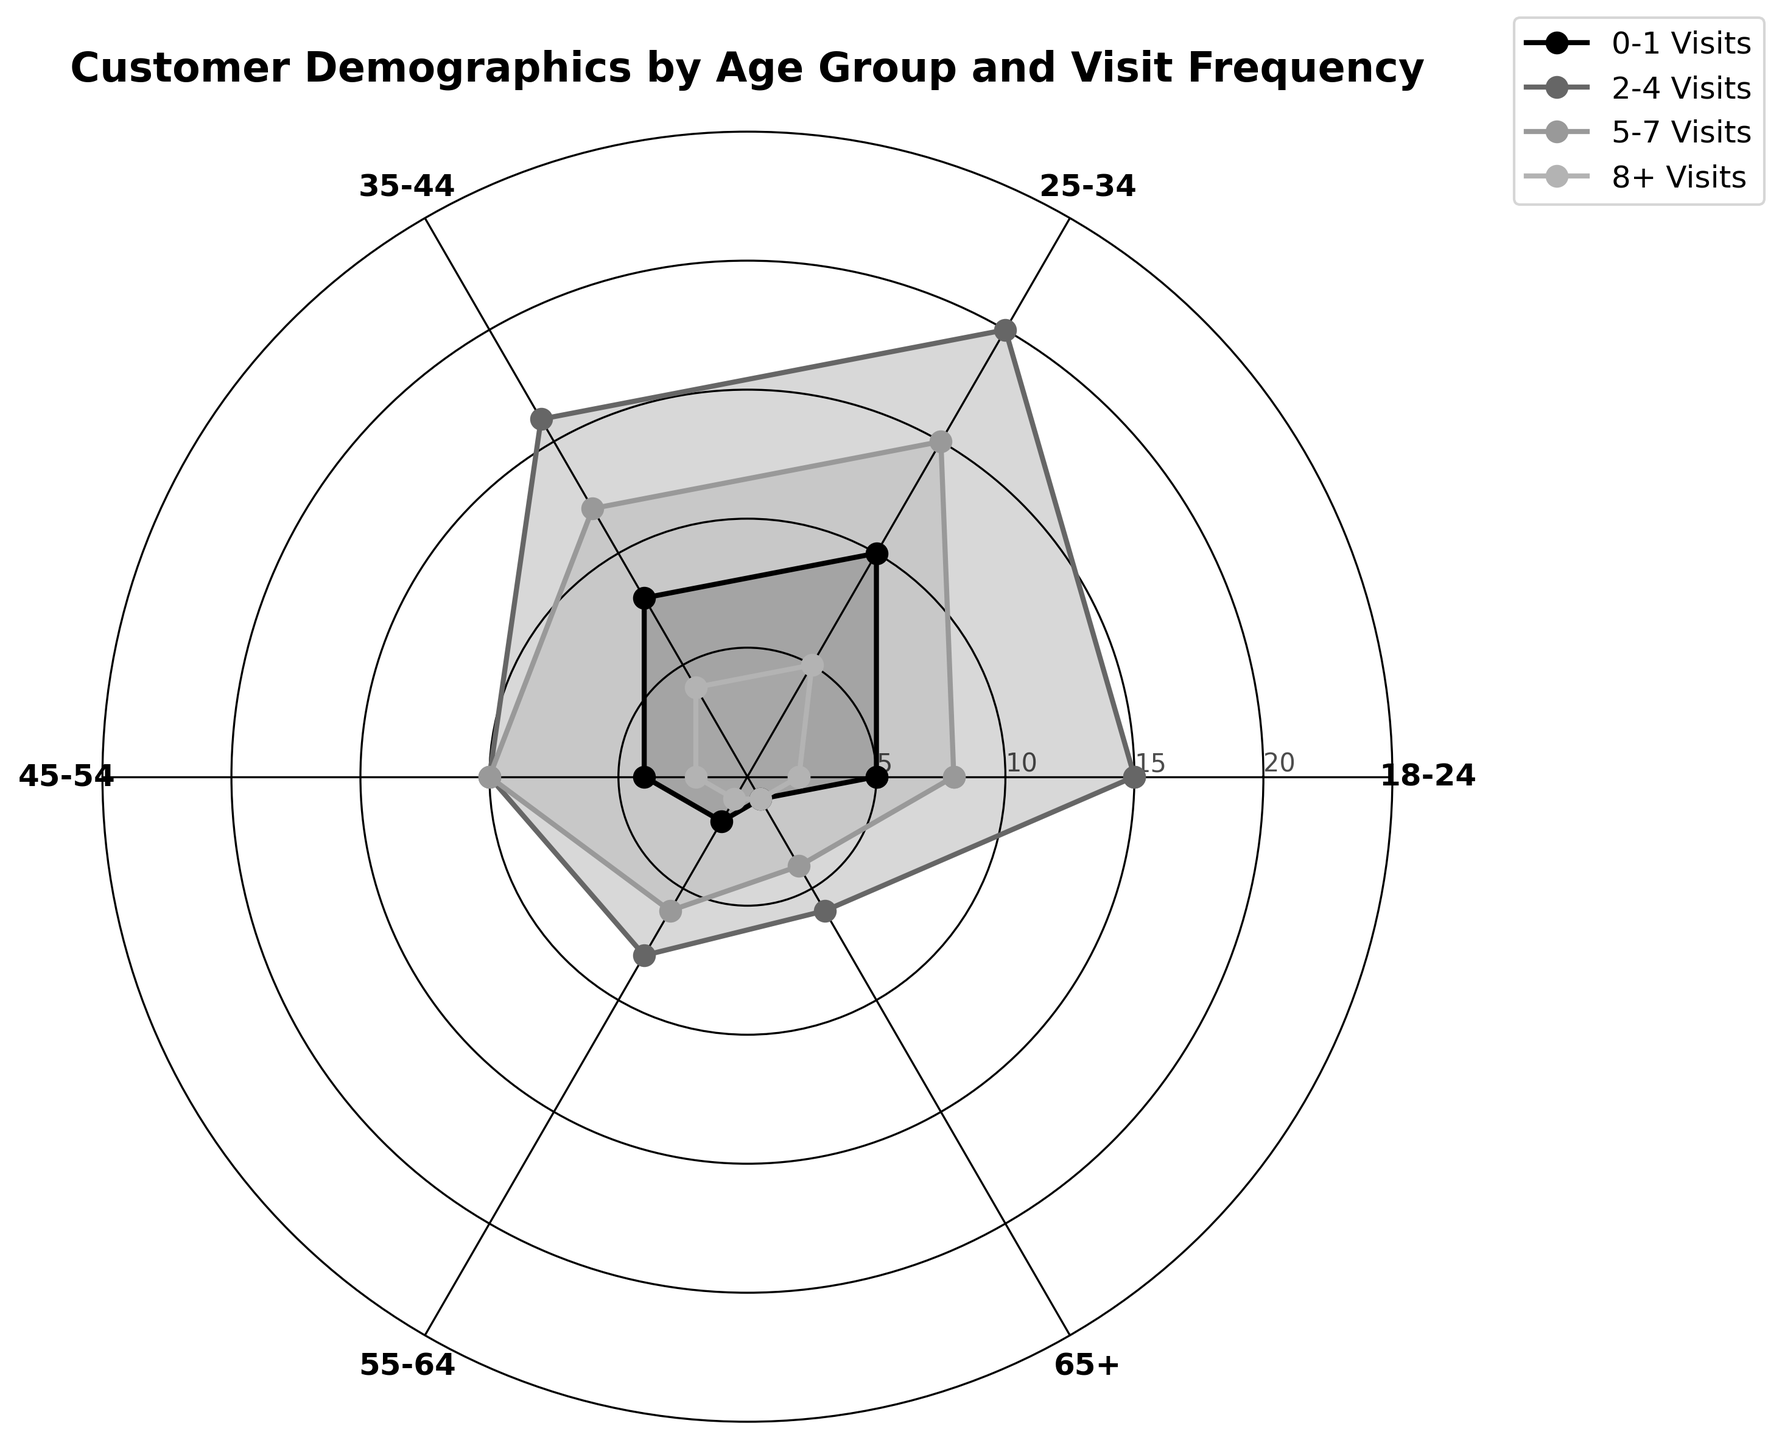What is the age group and visit frequency range being analyzed in the Polar Chart? The Polar Chart focuses on different age groups and how frequently they visit the restaurant per month. The age groups are 18-24, 25-34, 35-44, 45-54, 55-64, and 65+. The visit frequencies are categorized as 0-1 visits, 2-4 visits, 5-7 visits, and 8+ visits.
Answer: Age groups and visit frequencies Which age group has the highest number of customers with 2-4 visits per month? By examining the plot, the age group with the highest number of customers in the 2-4 visits per month category can be identified. This would be the data series that reaches the highest point on the numeric scale in the 2-4 visits category.
Answer: 25-34 Among the age groups 18-24 and 25-34, which one has more customers visiting 8+ times per month? To compare the two age groups for the 8+ visits category, observe the respective points plotted under that category. The age group that reaches a higher numeric value on the radial scale has more frequent visitors.
Answer: 25-34 What is the total number of customers aged 35-44 who visit the restaurant 0-1 times and 2-4 times per month? Add the values from the 35-44 age group for both the 0-1 visits and 2-4 visits categories. These values are 8 and 16, respectively. The sum yields the total number: 8 + 16 = 24.
Answer: 24 Which visit frequency category has the smallest number of customers across all age groups? Identify the category with the smallest values across all age groups by examining the radial extent of the plotted points around the circle. The category with values closest to the center has the fewest customers.
Answer: 8+ Visits How do the visit patterns of the 55-64 age group compare to those of the 18-24 age group in terms of 0-1 and 2-4 visits per month? Compare the values for the age groups 55-64 and 18-24 for the 0-1 visits and 2-4 visits categories by observing their position on the radial scale at these categories. For 0-1 visits, 55-64 has 2 and 18-24 has 5. For 2-4 visits, 55-64 has 8 and 18-24 has 15.
Answer: 18-24 is higher in both categories Which age group has the most evenly distributed visit frequencies? The most evenly distributed age group will have plotted points that are closest to each other on the radial scale across all categories. By observing the consistency of the plot's spread, it can be determined visually.
Answer: 35-44 How many total visits are recorded for the 45-54 age group? Add the values for all visit frequency categories in the 45-54 age group. These values are 4 (0-1 visits), 10 (2-4 visits), 10 (5-7 visits), and 2 (8+ visits). Total visits: 4 + 10 + 10 + 2 = 26.
Answer: 26 Which age group has the fewest number of customers in the 0-1 visits category, and how many are there? Identify the smallest value in the 0-1 visits category by examining the plotted points for all age groups. The smallest value in this category represents the fewest number of customers.
Answer: 65+ with 1 customer 